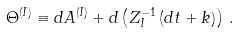<formula> <loc_0><loc_0><loc_500><loc_500>\Theta ^ { ( I ) } \equiv d A ^ { ( I ) } + d \left ( Z _ { I } ^ { - 1 } \, ( d t + k ) \right ) \, .</formula> 